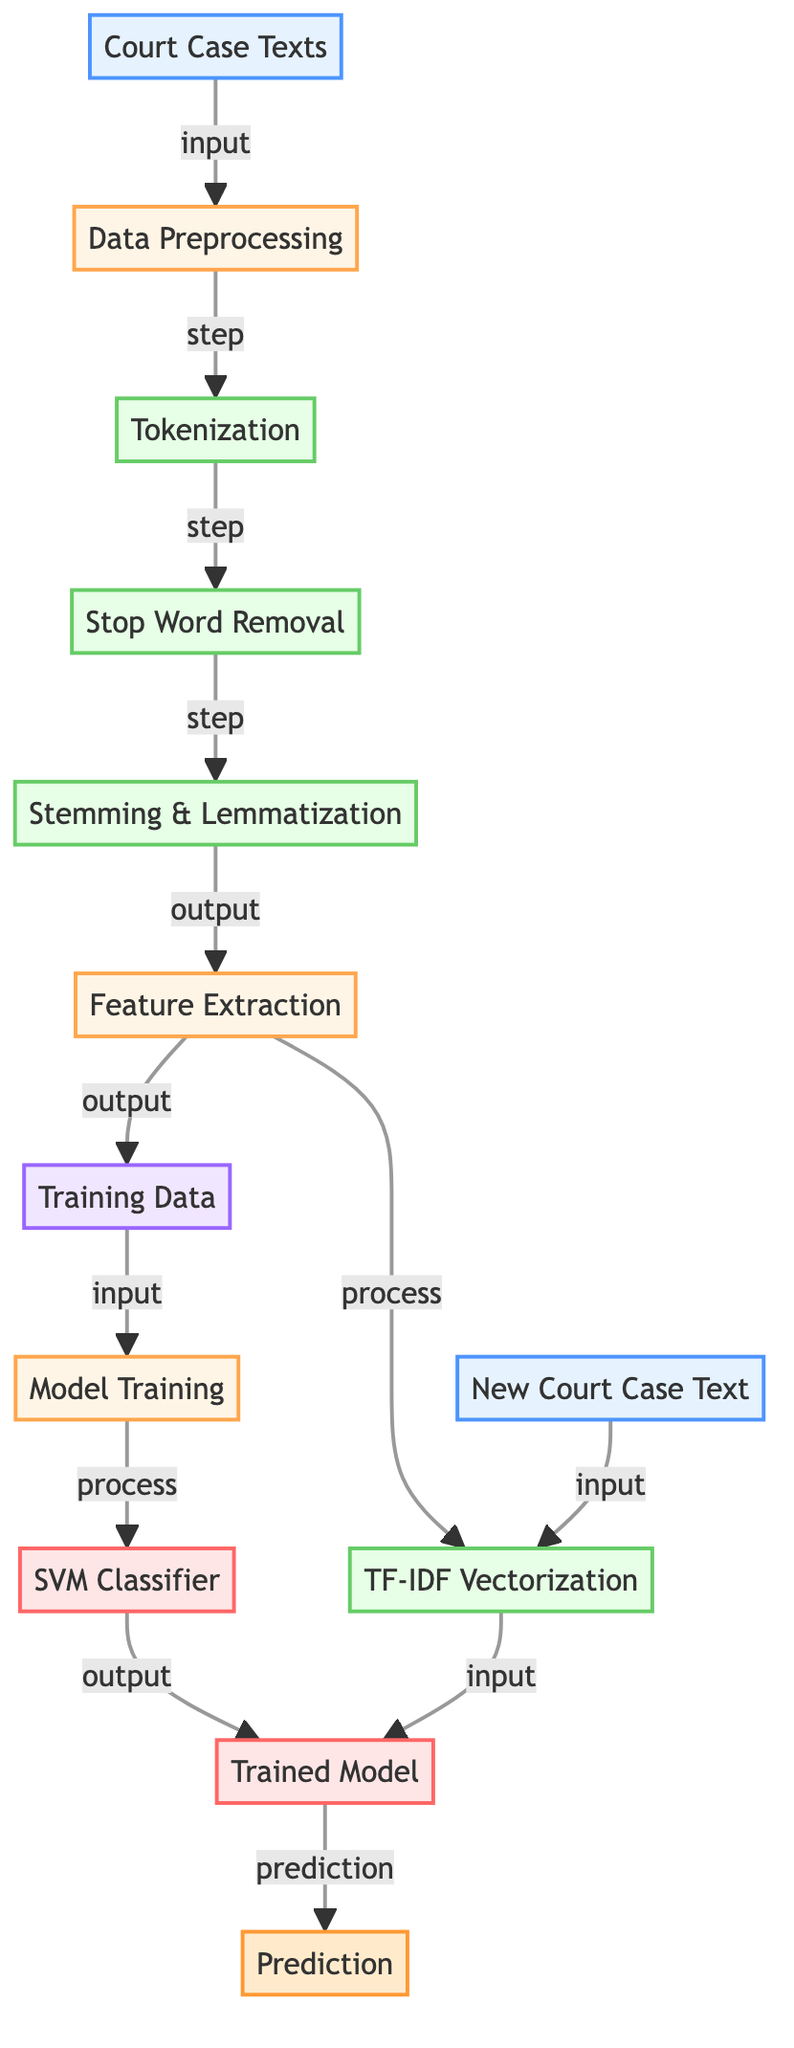What is the first step in the diagram? The first step is "Data Preprocessing," which processes the "Court Case Texts." It is visually the node immediately following the input node.
Answer: Data Preprocessing How many steps are there in the preprocessing phase? There are four steps in the preprocessing phase: Tokenization, Stop Word Removal, Stemming & Lemmatization, and Feature Extraction. Each of these is represented as a separate step node.
Answer: Four What does the output of the feature extraction step become? The output of the "Feature Extraction" step is "Training Data," as indicated by the arrow pointing from the feature extraction step to the training data.
Answer: Training Data Which node represents the model used for classification? The model used for classification is represented by the "SVM Classifier" node in the diagram, denoted as the node after the "Model Training" step.
Answer: SVM Classifier What is the relationship between the "New Court Case Text" and "Prediction"? The "New Court Case Text" serves as the input for "TF-IDF Vectorization," which then directly leads to the "Model Prediction," showing a flow from one to the other before arriving at the final prediction output.
Answer: Input to Prediction How is the "Trained Model" generated? The "Trained Model" is generated from the "Model Training" step, which uses "Training Data" as input and produces the model as output. This reflects a process where data is converted into the trained model for predictions.
Answer: From Training Data What is the role of the "TF-IDF Vectorization" in this diagram? The "TF-IDF Vectorization" takes on the role of transforming the textual data into a numerical format that the "SVM Classifier" can utilize for classification purposes, bridging the gap between feature extraction and model prediction.
Answer: Transforming textual data How many types of preprocessing steps are shown in the diagram? There are three types of preprocessing steps indicated here: Tokenization, Stop Word Removal, and Stemming & Lemmatization. Each of these is clearly represented as a separate step within the process of data preprocessing.
Answer: Three What connects "Training Data" and "Model Training" in this diagram? "Training Data" connects to "Model Training" as its input, indicating that it provides the necessary information for the model to learn and be trained during this process.
Answer: Input connection 